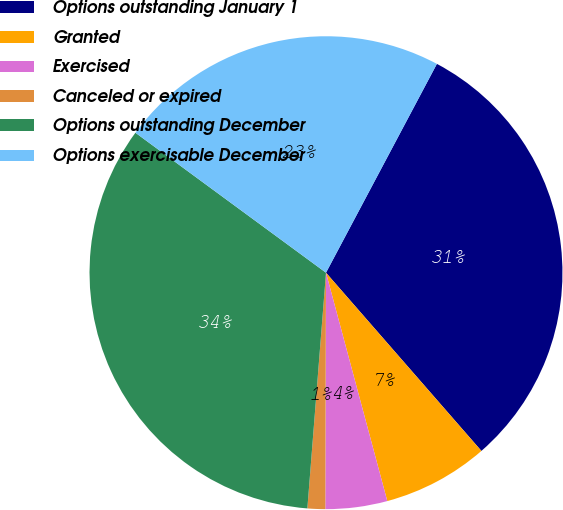Convert chart. <chart><loc_0><loc_0><loc_500><loc_500><pie_chart><fcel>Options outstanding January 1<fcel>Granted<fcel>Exercised<fcel>Canceled or expired<fcel>Options outstanding December<fcel>Options exercisable December<nl><fcel>30.82%<fcel>7.24%<fcel>4.22%<fcel>1.21%<fcel>33.83%<fcel>22.69%<nl></chart> 